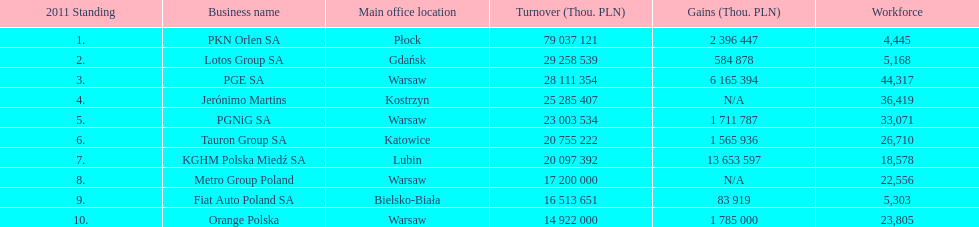How many firms generated over $1,000,000 in profit? 6. 